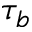Convert formula to latex. <formula><loc_0><loc_0><loc_500><loc_500>\tau _ { b }</formula> 